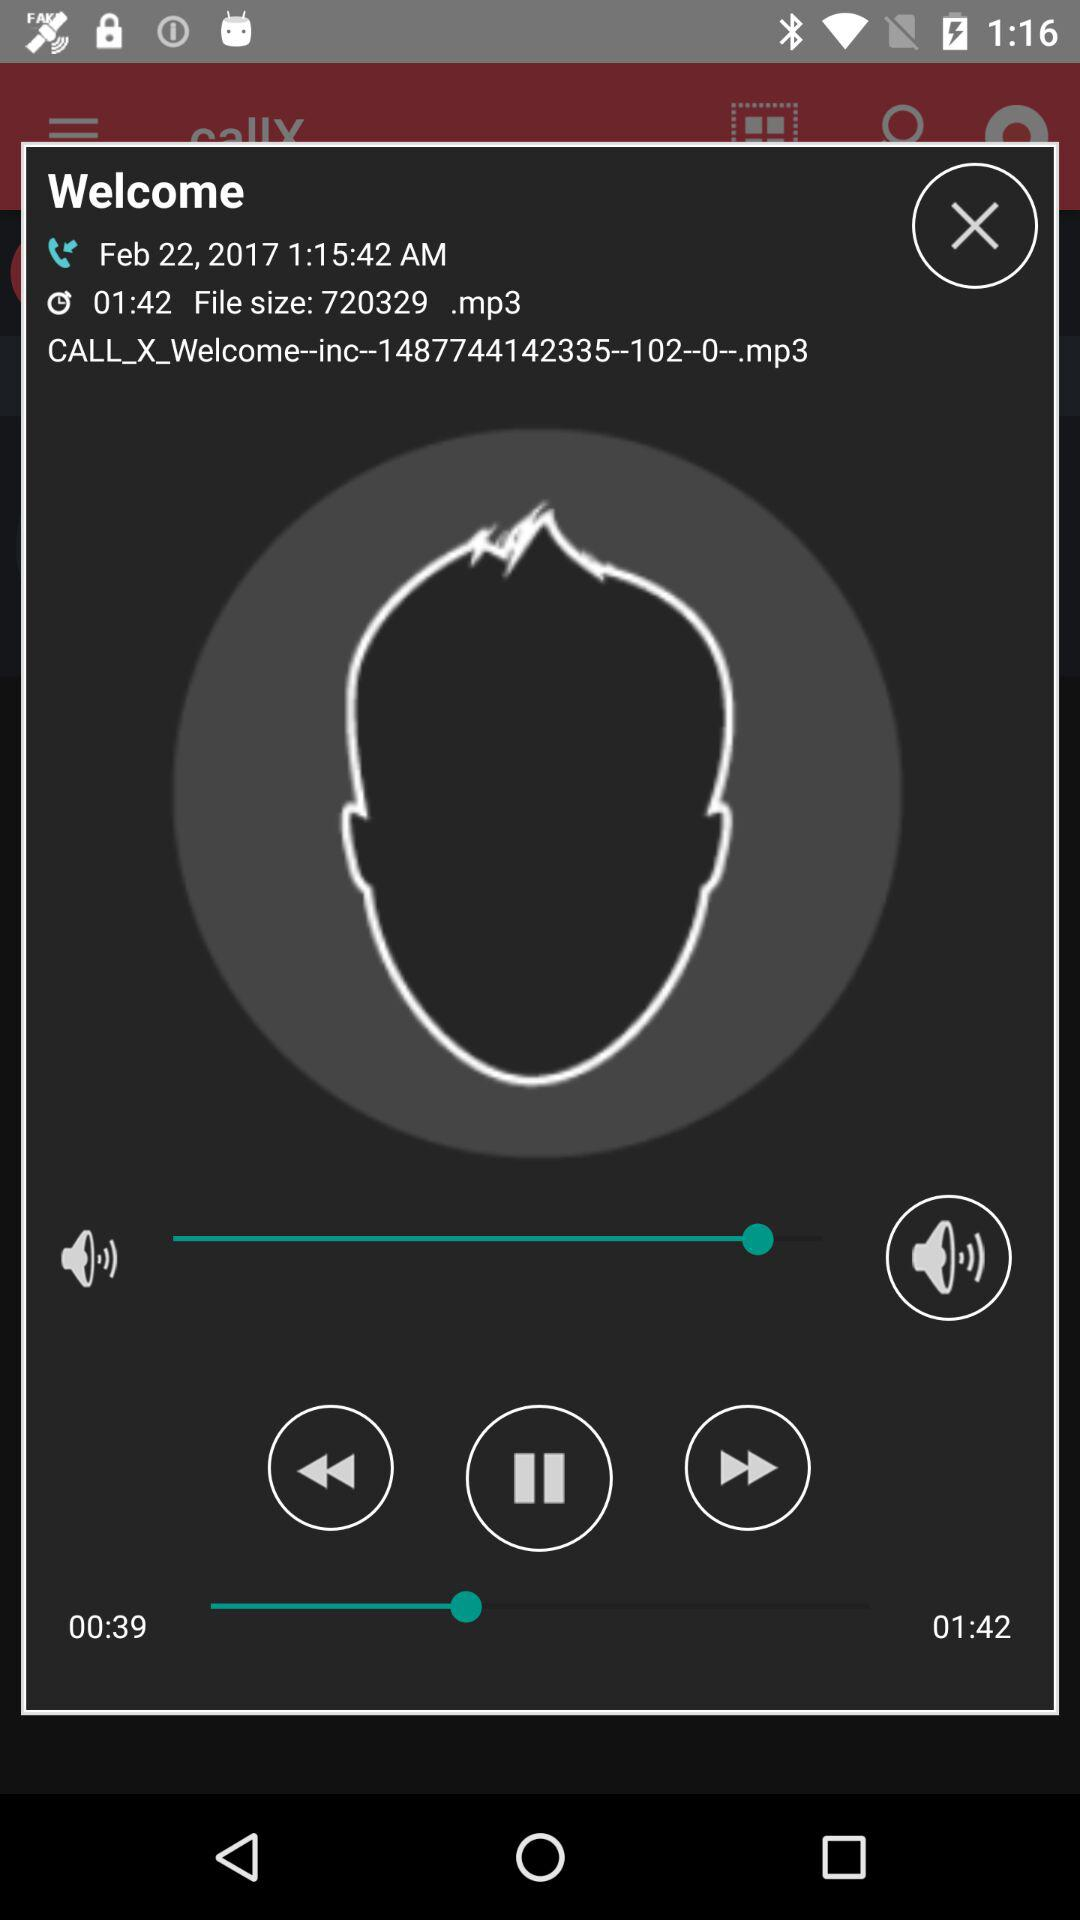What is the date of the call recording? The date is February 22, 2017. 